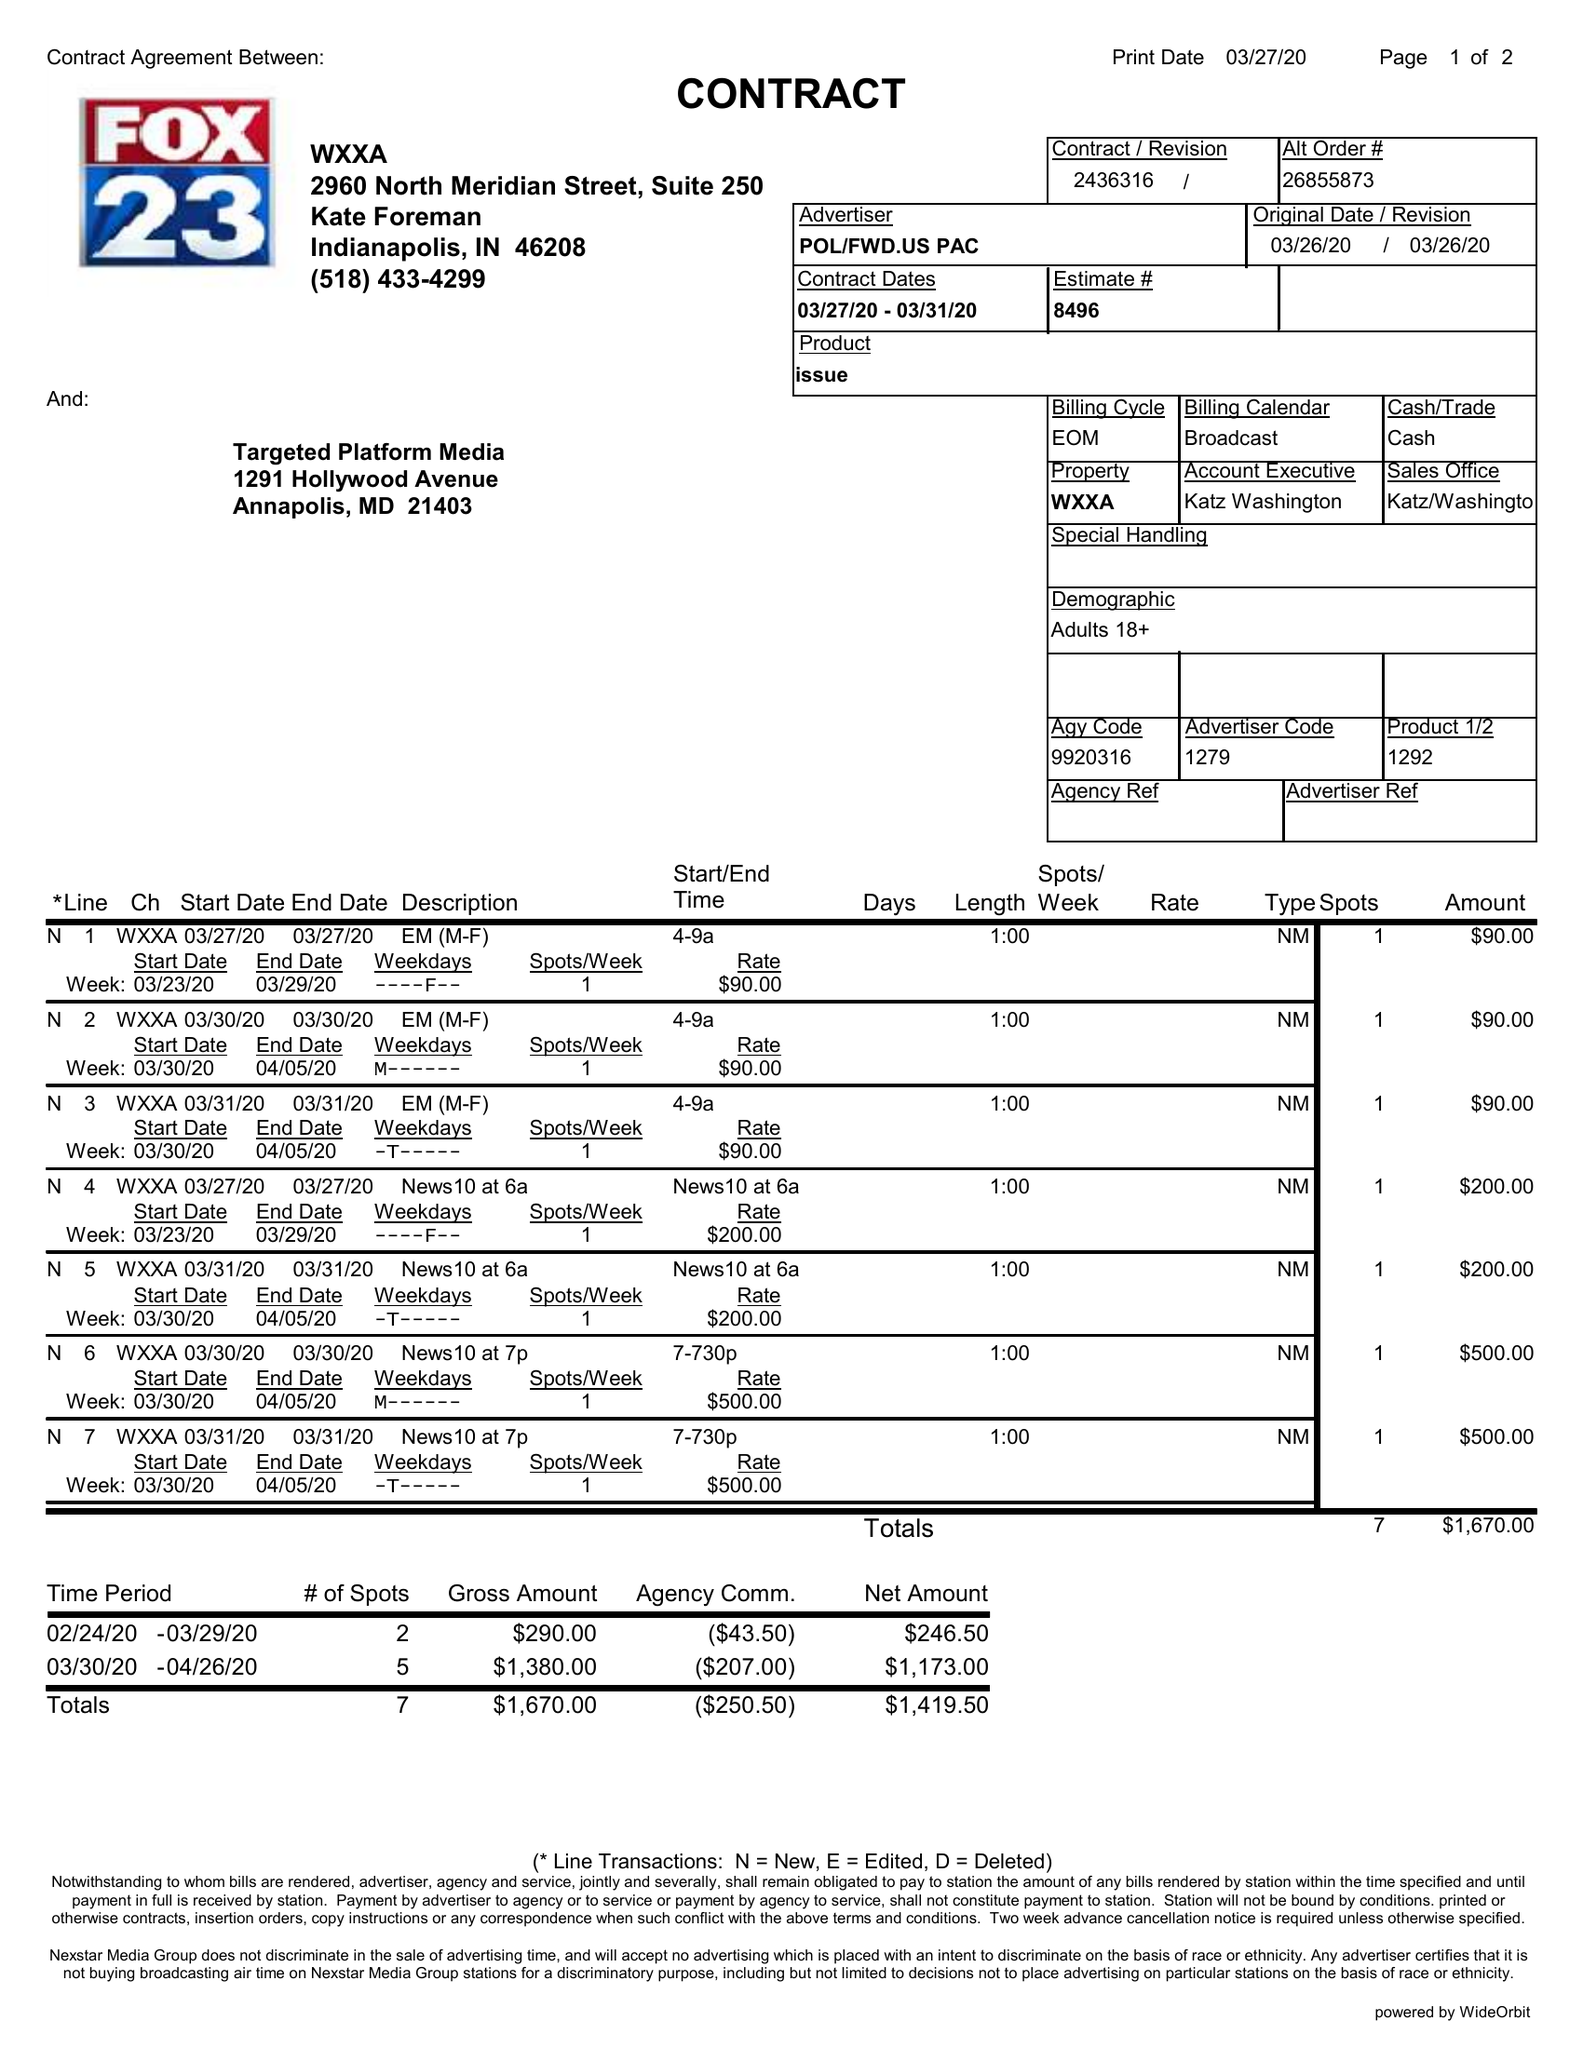What is the value for the flight_from?
Answer the question using a single word or phrase. 03/27/20 